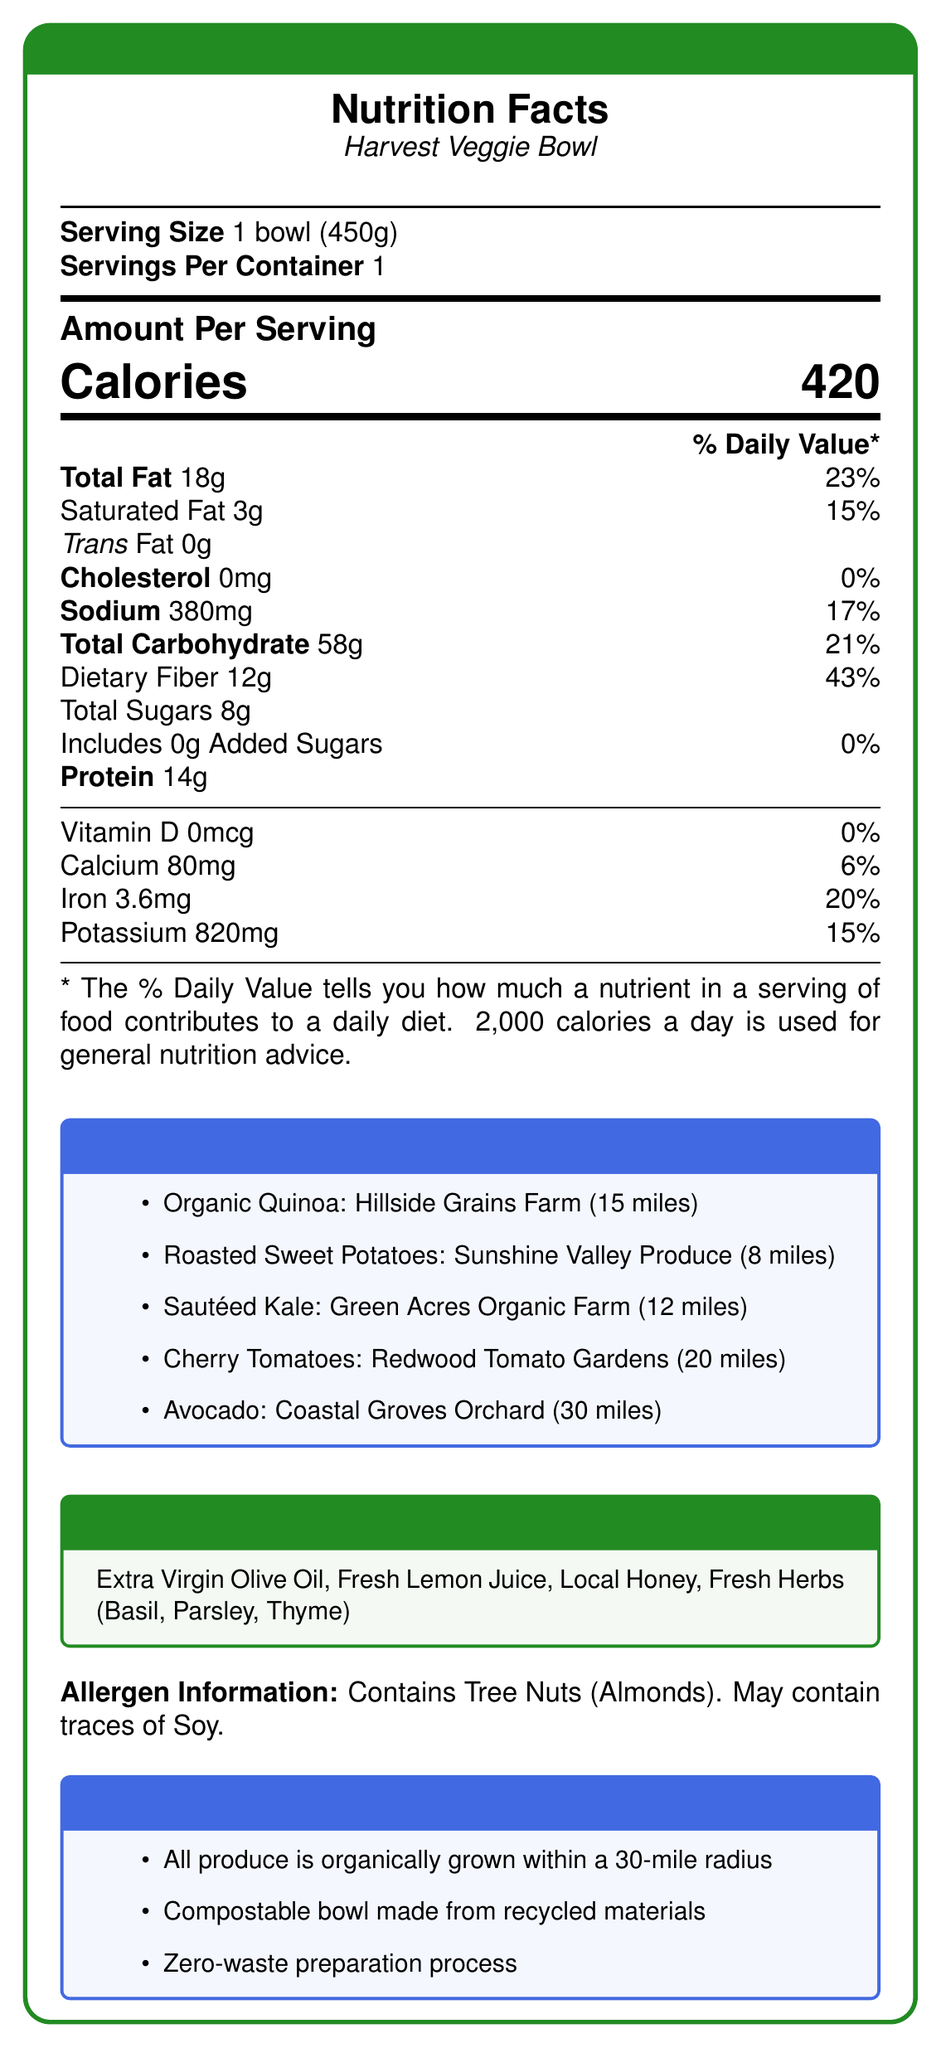what is the serving size? According to the document, the serving size is specified as 1 bowl which is 450g.
Answer: 1 bowl (450g) how many calories are in a serving? The document states that there are 420 calories in one serving of the Harvest Veggie Bowl.
Answer: 420 what percentage of the daily value is the total fat content? The total fat content is 18g which is 23% of the daily value as per the nutrition facts.
Answer: 23% what ingredients are locally sourced? The document lists locally sourced ingredients as Organic Quinoa, Roasted Sweet Potatoes, Sautéed Kale, Cherry Tomatoes, and Avocado, along with their sources and distances.
Answer: Organic Quinoa, Roasted Sweet Potatoes, Sautéed Kale, Cherry Tomatoes, Avocado what type of dressing is used in the Harvest Veggie Bowl? The document lists "Lemon Herb Vinaigrette" as the dressing used in the Harvest Veggie Bowl.
Answer: Lemon Herb Vinaigrette how much dietary fiber does the Harvest Veggie Bowl contain? The document specifies that the Harvest Veggie Bowl contains 12g of dietary fiber.
Answer: 12g what percentage of the daily value is the sodium content? The document shows that the sodium content is 380mg, which is 17% of the daily value.
Answer: 17% which farm provides the roasted sweet potatoes? The document states that the roasted sweet potatoes are sourced from Sunshine Valley Produce, which is 8 miles away.
Answer: Sunshine Valley Produce which ingredient is sourced from Coastal Groves Orchard? A. Organic Quinoa B. Avocado C. Sautéed Kale D. Cherry Tomatoes According to the document, the Avocado is sourced from Coastal Groves Orchard, which is 30 miles away.
Answer: B. Avocado how many grams of protein are in one serving of the Harvest Veggie Bowl? A. 10g B. 12g C. 14g D. 16g The document lists that there are 14 grams of protein in one serving of the Harvest Veggie Bowl.
Answer: C. 14g does the Harvest Veggie Bowl contain any added sugars? The document states that the Harvest Veggie Bowl includes 0g of added sugars.
Answer: No is the bowl used for serving the Harvest Veggie Bowl compostable? The document mentions in the sustainability notes that the bowl is made from compostable materials.
Answer: Yes is the Harvest Veggie Bowl suitable for someone with a nut allergy? The allergen information indicates that the Harvest Veggie Bowl contains tree nuts (Almonds), which means it is not suitable for someone with a nut allergy.
Answer: No does the document provide any details about the zero-waste preparation process? The document mentions a zero-waste preparation process but does not provide detailed information about it.
Answer: Not enough information summarize the main points of the document. The document provides an overview of the Harvest Veggie Bowl's nutritional content, locally sourced ingredients, allergen details, dressing ingredients, and sustainability practices, reflecting Farm Fresh Bistro's commitment to organic and sustainable practices.
Answer: The document is a Nutrition Facts Label for the Harvest Veggie Bowl from Farm Fresh Bistro. It includes detailed nutritional information, highlighting locally sourced ingredients, and mentions the use of a Lemon Herb Vinaigrette. The document also provides allergen information, sustainability notes, and emphasizes the farm-to-table approach with organically grown produce sourced within a 30-mile radius. 